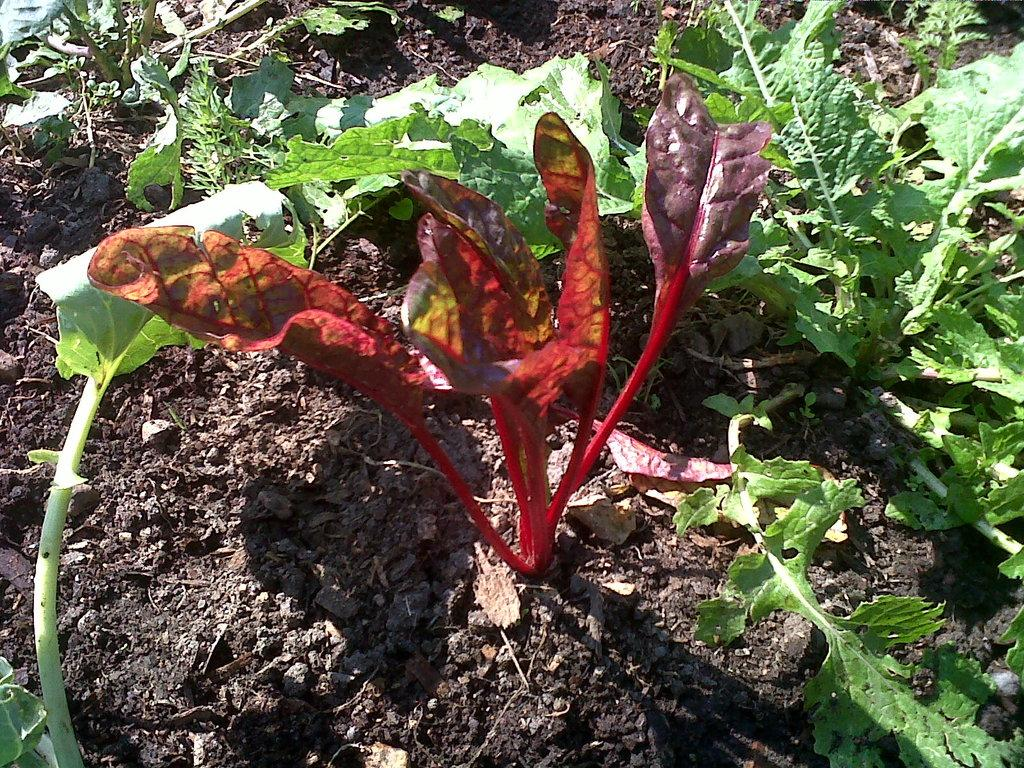What type of living organisms can be seen in the image? Plants can be seen in the image. Where are the plants located? The plants are on the surface. What type of business is being conducted in the cave in the image? There is no cave or business present in the image; it features plants on the surface. What type of lace can be seen on the plants in the image? There is no lace present on the plants in the image; they are simply plants on the surface. 